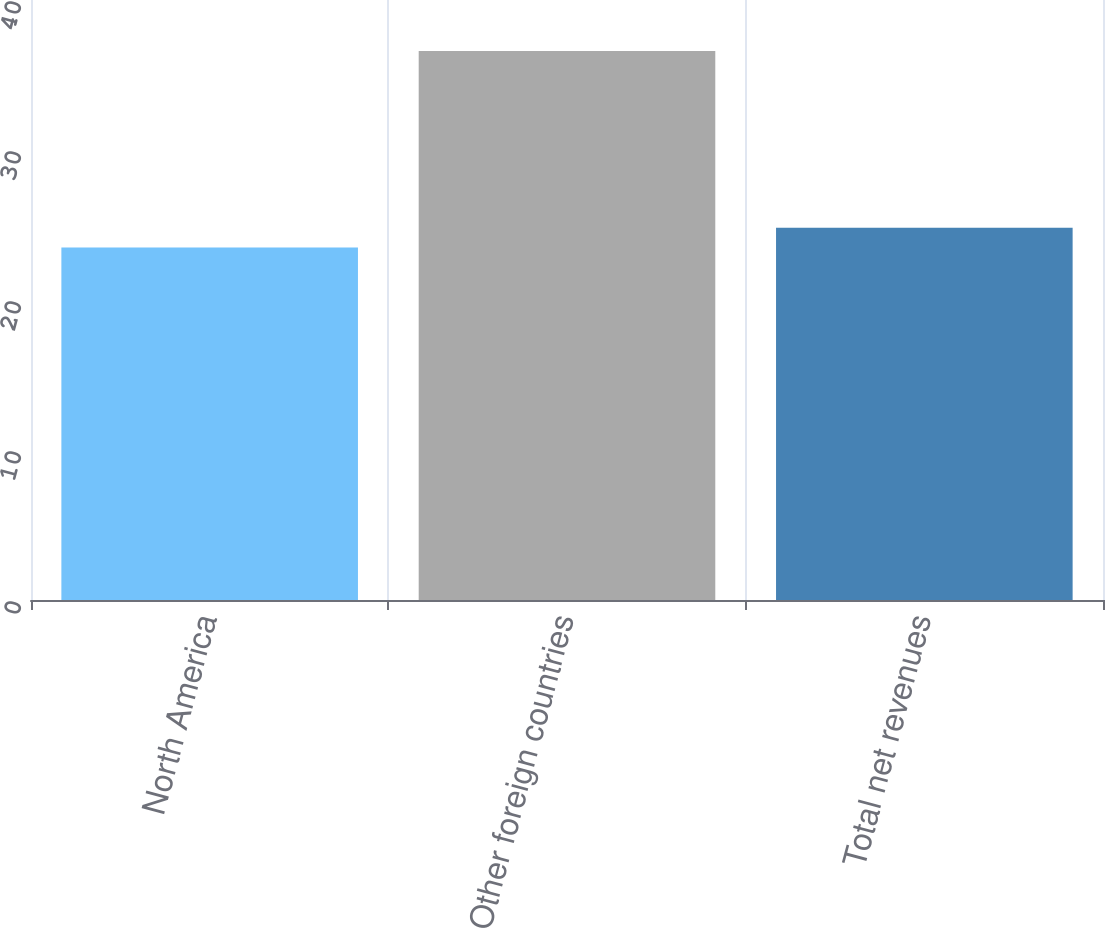<chart> <loc_0><loc_0><loc_500><loc_500><bar_chart><fcel>North America<fcel>Other foreign countries<fcel>Total net revenues<nl><fcel>23.5<fcel>36.6<fcel>24.81<nl></chart> 